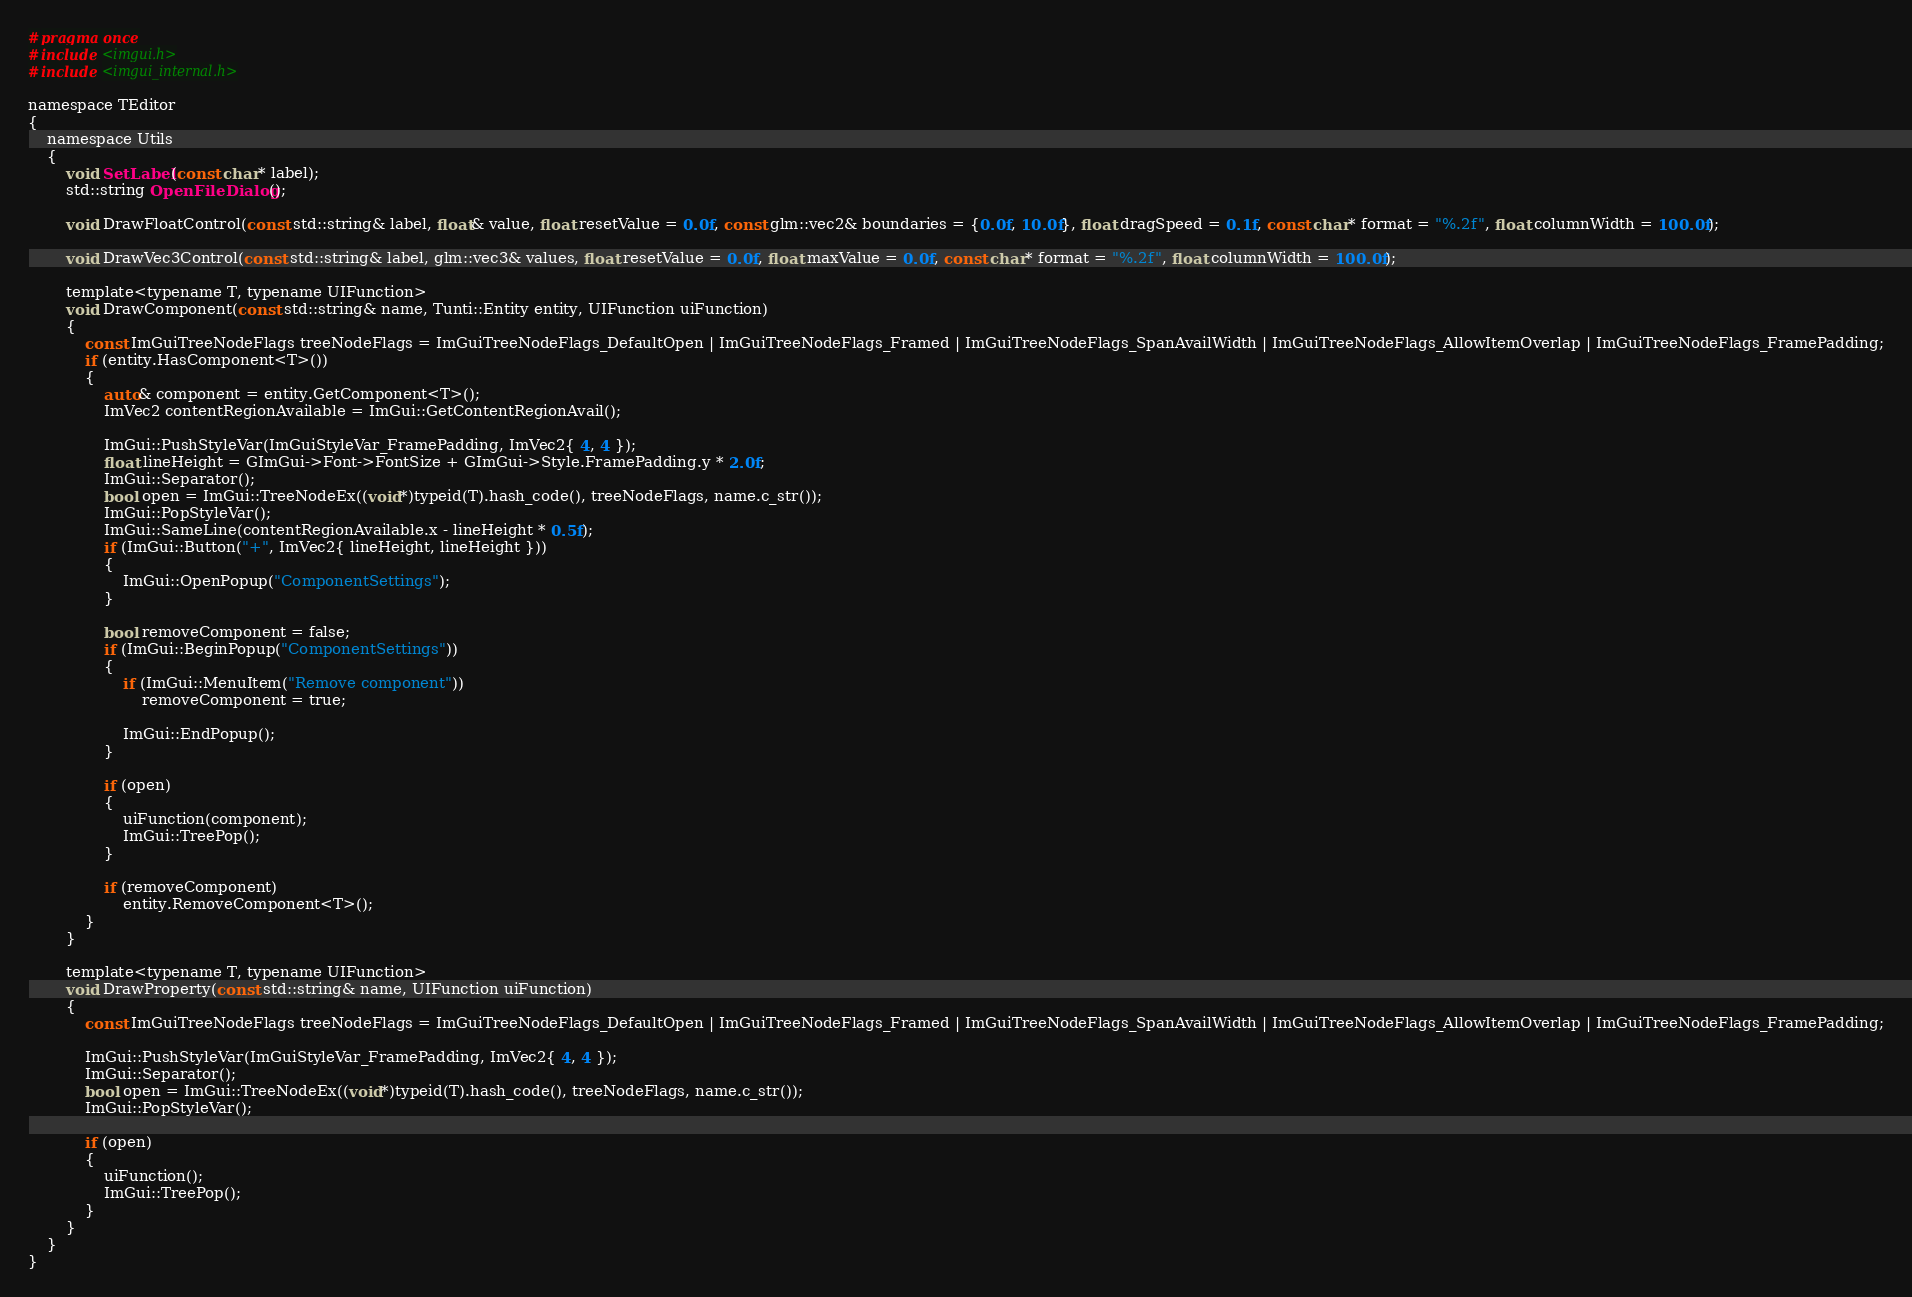<code> <loc_0><loc_0><loc_500><loc_500><_C_>#pragma once
#include <imgui.h>
#include <imgui_internal.h>

namespace TEditor
{
	namespace Utils
	{
		void SetLabel(const char* label);
		std::string OpenFileDialog();

		void DrawFloatControl(const std::string& label, float& value, float resetValue = 0.0f, const glm::vec2& boundaries = {0.0f, 10.0f}, float dragSpeed = 0.1f, const char* format = "%.2f", float columnWidth = 100.0f);

		void DrawVec3Control(const std::string& label, glm::vec3& values, float resetValue = 0.0f, float maxValue = 0.0f, const char* format = "%.2f", float columnWidth = 100.0f);

		template<typename T, typename UIFunction>
		void DrawComponent(const std::string& name, Tunti::Entity entity, UIFunction uiFunction)
		{
			const ImGuiTreeNodeFlags treeNodeFlags = ImGuiTreeNodeFlags_DefaultOpen | ImGuiTreeNodeFlags_Framed | ImGuiTreeNodeFlags_SpanAvailWidth | ImGuiTreeNodeFlags_AllowItemOverlap | ImGuiTreeNodeFlags_FramePadding;
			if (entity.HasComponent<T>())
			{
				auto& component = entity.GetComponent<T>();
				ImVec2 contentRegionAvailable = ImGui::GetContentRegionAvail();

				ImGui::PushStyleVar(ImGuiStyleVar_FramePadding, ImVec2{ 4, 4 });
				float lineHeight = GImGui->Font->FontSize + GImGui->Style.FramePadding.y * 2.0f;
				ImGui::Separator();
				bool open = ImGui::TreeNodeEx((void*)typeid(T).hash_code(), treeNodeFlags, name.c_str());
				ImGui::PopStyleVar();
				ImGui::SameLine(contentRegionAvailable.x - lineHeight * 0.5f);
				if (ImGui::Button("+", ImVec2{ lineHeight, lineHeight }))
				{
					ImGui::OpenPopup("ComponentSettings");
				}

				bool removeComponent = false;
				if (ImGui::BeginPopup("ComponentSettings"))
				{
					if (ImGui::MenuItem("Remove component"))
						removeComponent = true;

					ImGui::EndPopup();
				}

				if (open)
				{
					uiFunction(component);
					ImGui::TreePop();
				}

				if (removeComponent)
					entity.RemoveComponent<T>();
			}
		}

		template<typename T, typename UIFunction>
		void DrawProperty(const std::string& name, UIFunction uiFunction)
		{
			const ImGuiTreeNodeFlags treeNodeFlags = ImGuiTreeNodeFlags_DefaultOpen | ImGuiTreeNodeFlags_Framed | ImGuiTreeNodeFlags_SpanAvailWidth | ImGuiTreeNodeFlags_AllowItemOverlap | ImGuiTreeNodeFlags_FramePadding;
			
			ImGui::PushStyleVar(ImGuiStyleVar_FramePadding, ImVec2{ 4, 4 });
			ImGui::Separator();
			bool open = ImGui::TreeNodeEx((void*)typeid(T).hash_code(), treeNodeFlags, name.c_str());
			ImGui::PopStyleVar();

			if (open)
			{
				uiFunction();
				ImGui::TreePop();
			}	
		}
	}
}</code> 